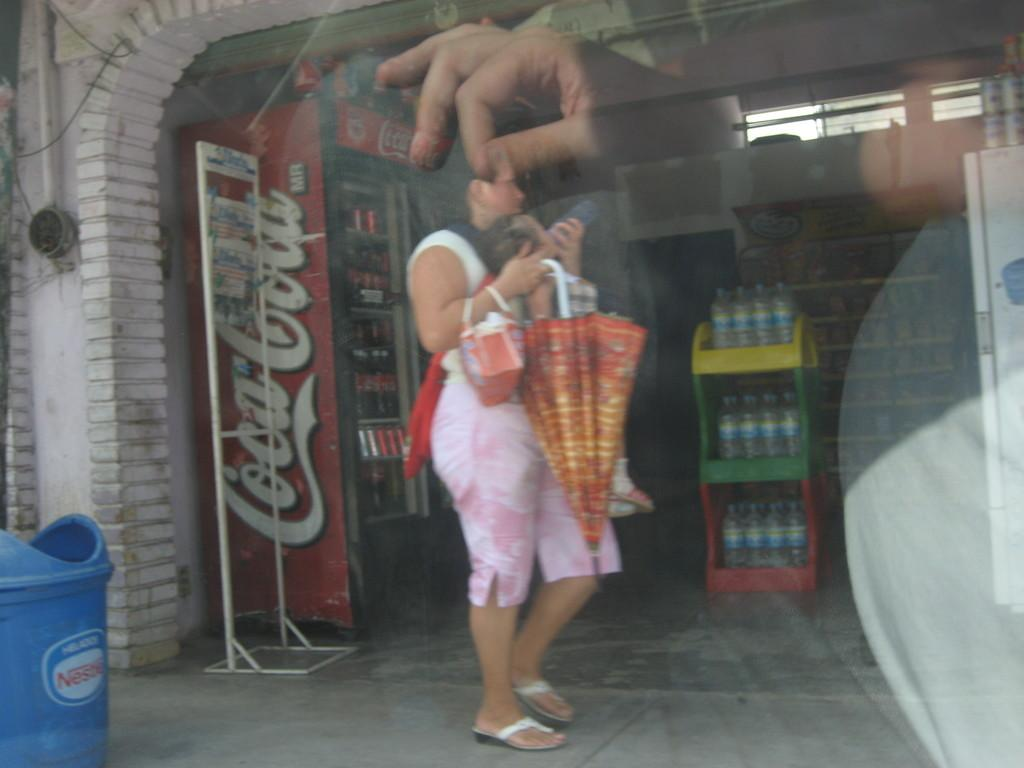<image>
Summarize the visual content of the image. Man using his reflection on the window to make it look like he is pinching the head of a female pedestrian as she walks by a Coca-Cola machine. 